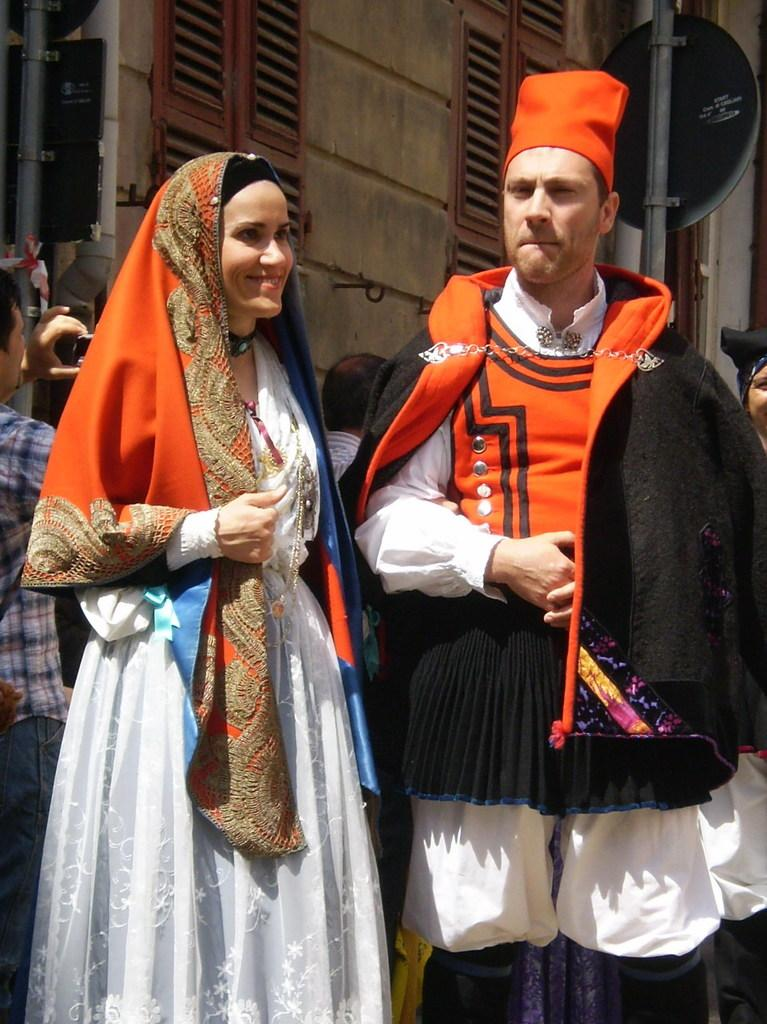Who are the two people in the image? There is a man and a woman standing in the image. What can be seen in the background of the image? There are few persons, a window, doors, a wall, and boards on poles in the background of the image. Can you describe the man on the left side of the image? There is a man on the left side of the image holding an object in his hands. What type of toothpaste is the woman using in the image? There is no toothpaste present in the image. What kind of farm animals can be seen in the background of the image? There are no farm animals visible in the image. 